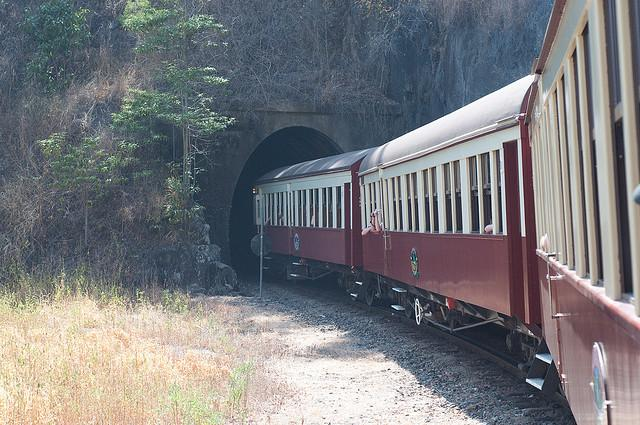If the train continues forward what will make it go out of sight first?

Choices:
A) bridge
B) building
C) tunnel
D) extreme distance tunnel 